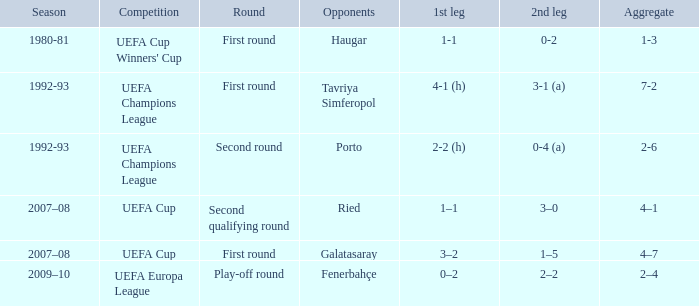 what's the competition where aggregate is 4–7 UEFA Cup. 